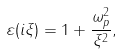Convert formula to latex. <formula><loc_0><loc_0><loc_500><loc_500>\varepsilon ( i \xi ) = 1 + \frac { \omega _ { p } ^ { 2 } } { \xi ^ { 2 } } ,</formula> 